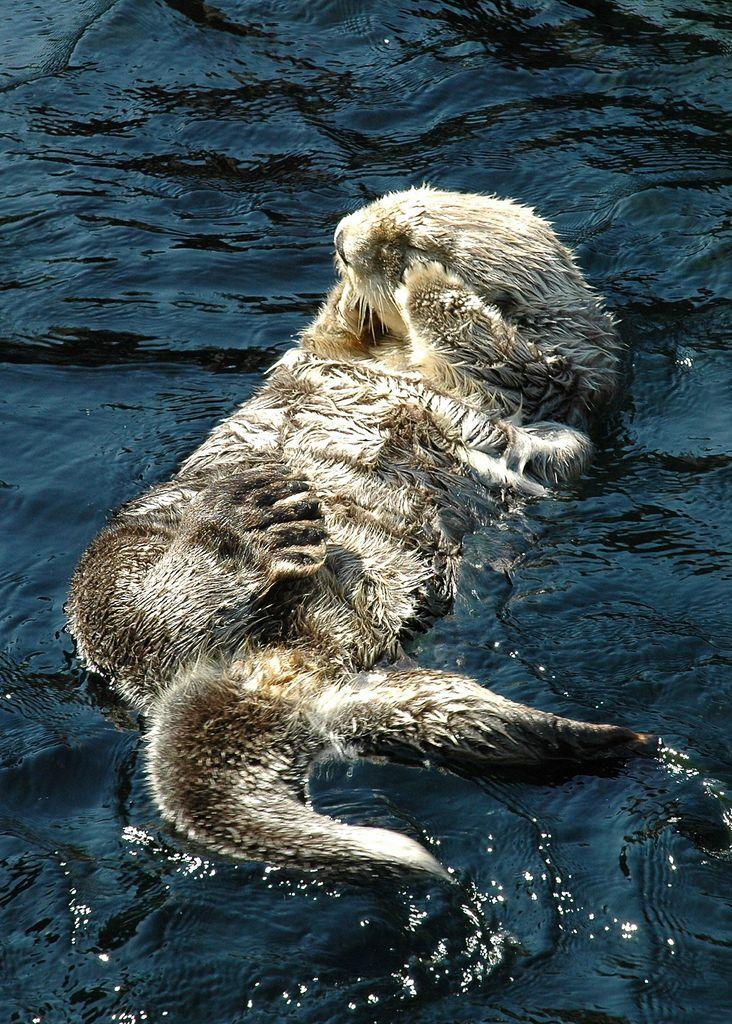What animal is present in the image? There is a sea otter in the image. Where is the sea otter located? The sea otter is in the water. What type of meal is the sea otter preparing in the image? There is no indication in the image that the sea otter is preparing a meal, as sea otters typically eat while floating on their backs. 